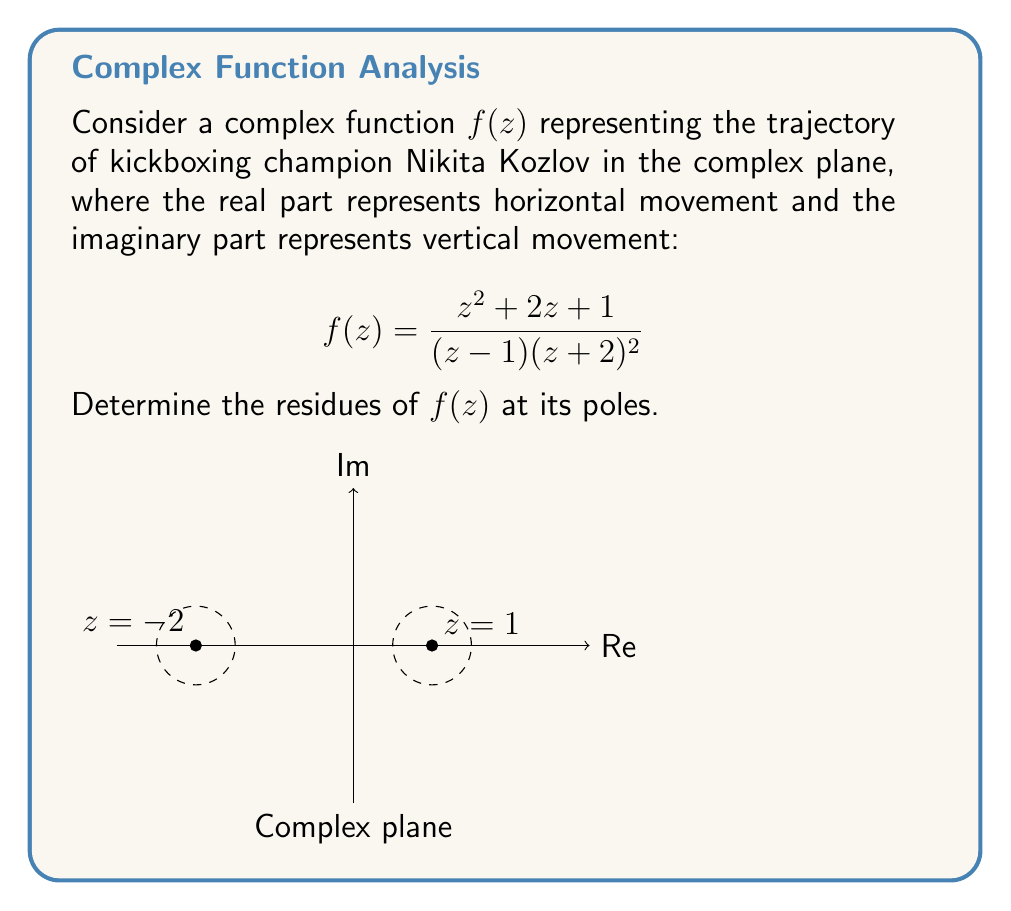Could you help me with this problem? To find the residues, we need to identify the poles of $f(z)$ and their orders:

1. At $z = 1$: simple pole (order 1)
2. At $z = -2$: double pole (order 2)

For the simple pole at $z = 1$:
The residue is given by:
$$\text{Res}(f,1) = \lim_{z \to 1} (z-1)f(z) = \lim_{z \to 1} \frac{z^2 + 2z + 1}{(z+2)^2} = \frac{1^2 + 2(1) + 1}{(1+2)^2} = \frac{4}{9}$$

For the double pole at $z = -2$:
The residue is given by:
$$\text{Res}(f,-2) = \lim_{z \to -2} \frac{d}{dz}[(z+2)^2f(z)]$$

Let $g(z) = (z+2)^2f(z) = \frac{z^2 + 2z + 1}{z-1}$

$$\frac{d}{dz}g(z) = \frac{(2z+2)(z-1) - (z^2+2z+1)(-1)}{(z-1)^2}$$

Evaluating at $z = -2$:
$$\text{Res}(f,-2) = \frac{(-4+2)(-3) - (4-4+1)}{(-3)^2} = \frac{-6 - 1}{9} = -\frac{7}{9}$$
Answer: $\text{Res}(f,1) = \frac{4}{9}$, $\text{Res}(f,-2) = -\frac{7}{9}$ 